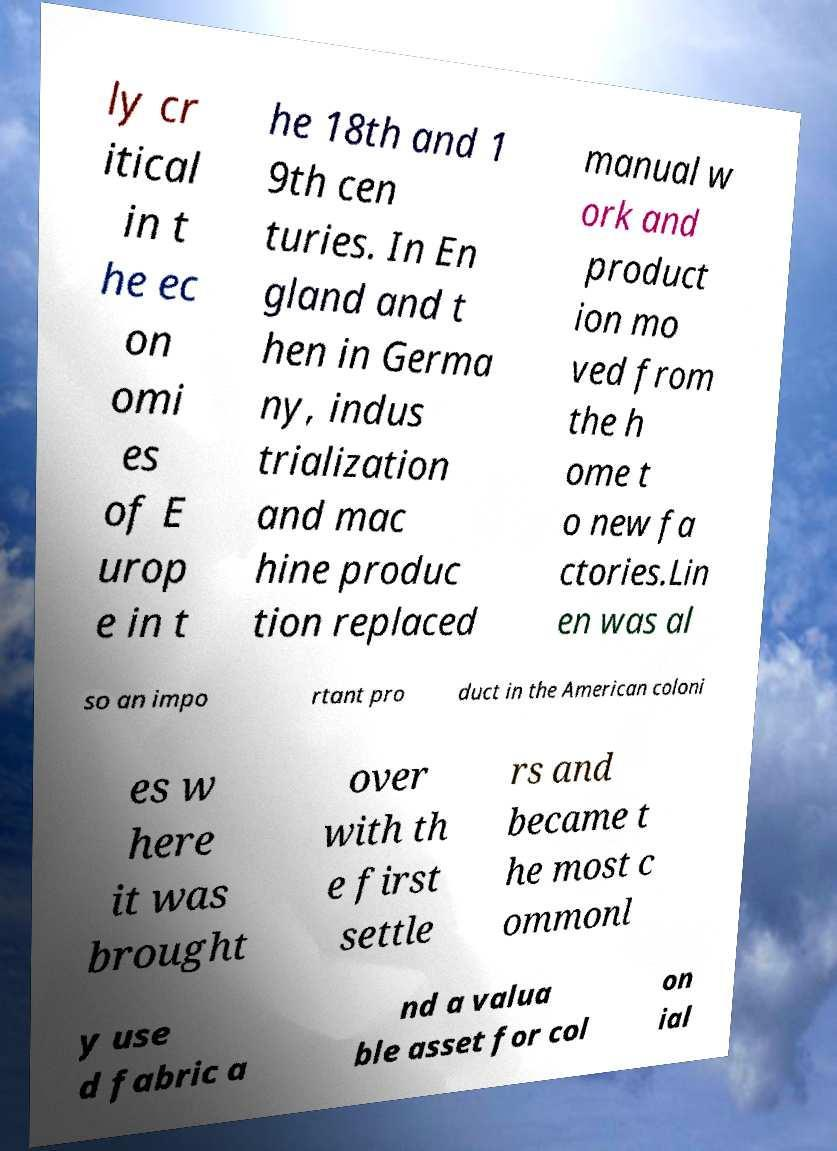Can you accurately transcribe the text from the provided image for me? ly cr itical in t he ec on omi es of E urop e in t he 18th and 1 9th cen turies. In En gland and t hen in Germa ny, indus trialization and mac hine produc tion replaced manual w ork and product ion mo ved from the h ome t o new fa ctories.Lin en was al so an impo rtant pro duct in the American coloni es w here it was brought over with th e first settle rs and became t he most c ommonl y use d fabric a nd a valua ble asset for col on ial 